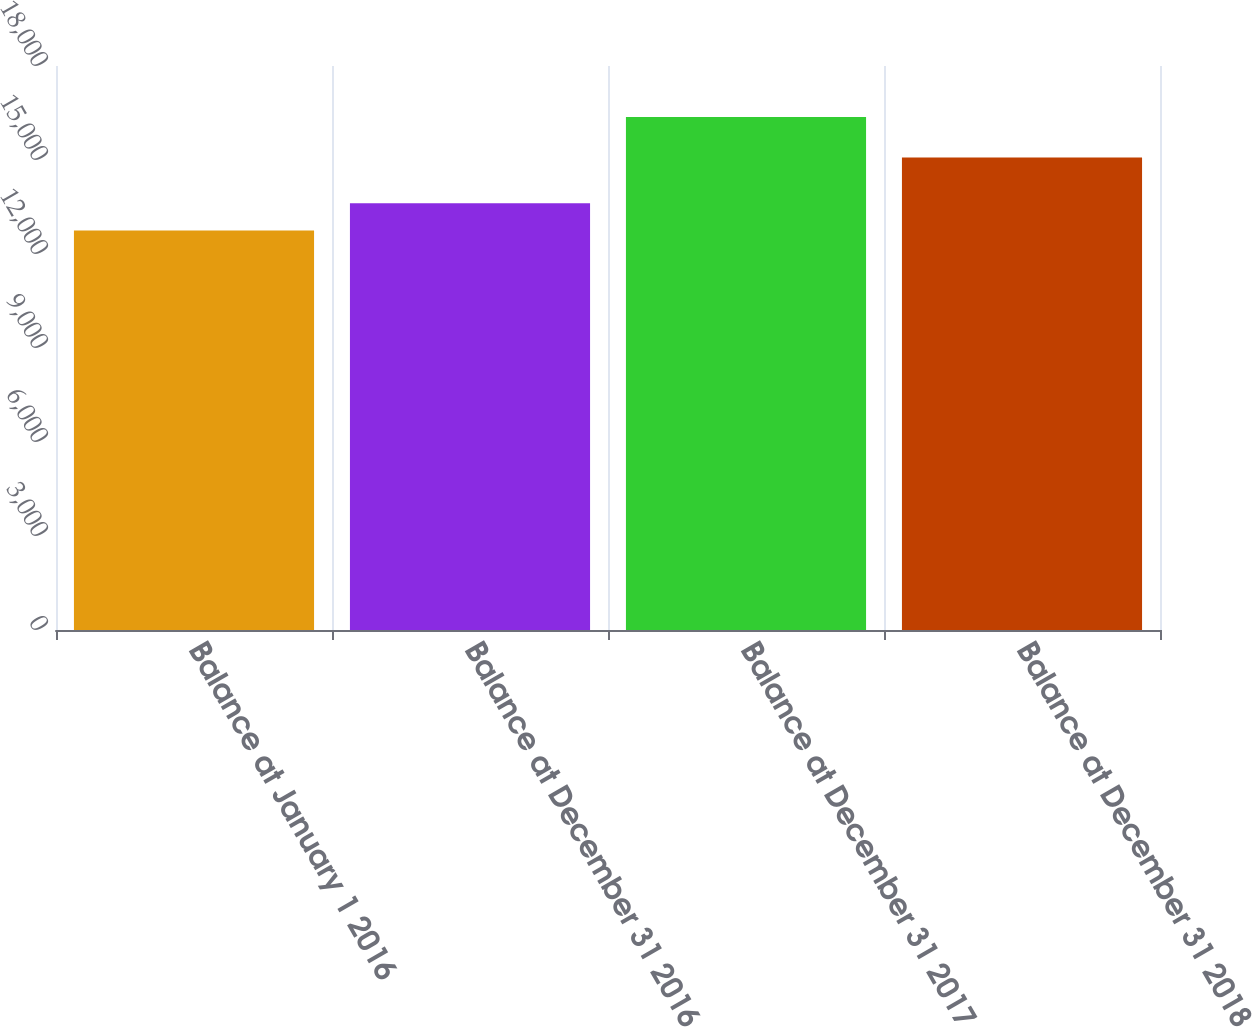Convert chart to OTSL. <chart><loc_0><loc_0><loc_500><loc_500><bar_chart><fcel>Balance at January 1 2016<fcel>Balance at December 31 2016<fcel>Balance at December 31 2017<fcel>Balance at December 31 2018<nl><fcel>12748<fcel>13623<fcel>16373<fcel>15083<nl></chart> 